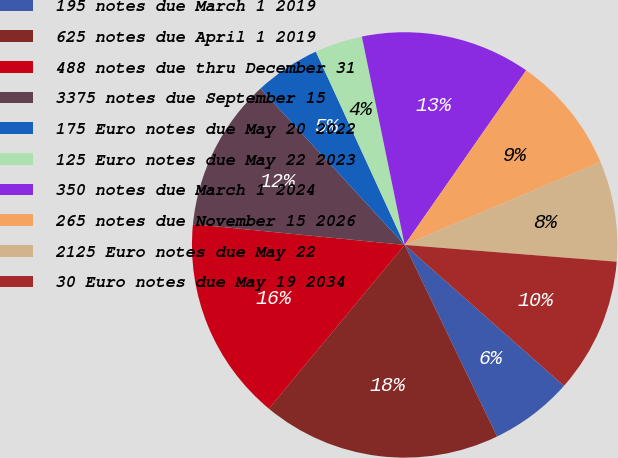Convert chart to OTSL. <chart><loc_0><loc_0><loc_500><loc_500><pie_chart><fcel>195 notes due March 1 2019<fcel>625 notes due April 1 2019<fcel>488 notes due thru December 31<fcel>3375 notes due September 15<fcel>175 Euro notes due May 20 2022<fcel>125 Euro notes due May 22 2023<fcel>350 notes due March 1 2024<fcel>265 notes due November 15 2026<fcel>2125 Euro notes due May 22<fcel>30 Euro notes due May 19 2034<nl><fcel>6.32%<fcel>18.17%<fcel>15.54%<fcel>11.59%<fcel>5.0%<fcel>3.63%<fcel>12.9%<fcel>8.95%<fcel>7.63%<fcel>10.27%<nl></chart> 